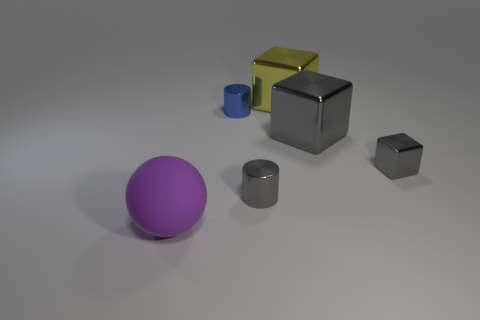Is there anything else that is the same shape as the purple rubber object?
Make the answer very short. No. Are there fewer large things in front of the blue metallic cylinder than things on the left side of the big yellow shiny block?
Provide a short and direct response. Yes. How many shiny objects are small brown objects or tiny gray cylinders?
Your answer should be very brief. 1. What is the shape of the big purple object?
Give a very brief answer. Sphere. There is a yellow block that is the same size as the rubber ball; what material is it?
Offer a very short reply. Metal. What number of big things are either gray metal cylinders or blue matte blocks?
Offer a terse response. 0. Are any blue metallic objects visible?
Make the answer very short. Yes. The cylinder that is the same material as the blue thing is what size?
Provide a short and direct response. Small. Is the material of the yellow cube the same as the big gray cube?
Provide a short and direct response. Yes. How many other things are the same material as the large purple thing?
Your answer should be compact. 0. 